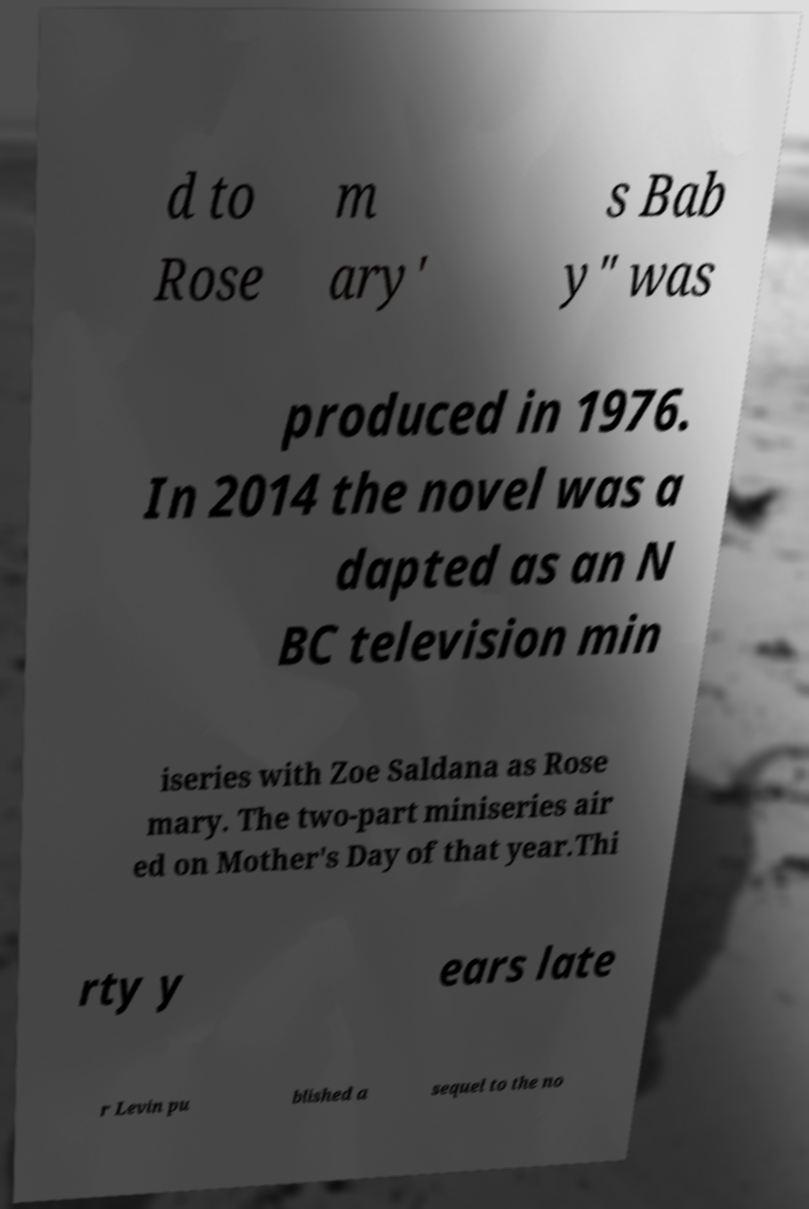I need the written content from this picture converted into text. Can you do that? d to Rose m ary' s Bab y" was produced in 1976. In 2014 the novel was a dapted as an N BC television min iseries with Zoe Saldana as Rose mary. The two-part miniseries air ed on Mother's Day of that year.Thi rty y ears late r Levin pu blished a sequel to the no 